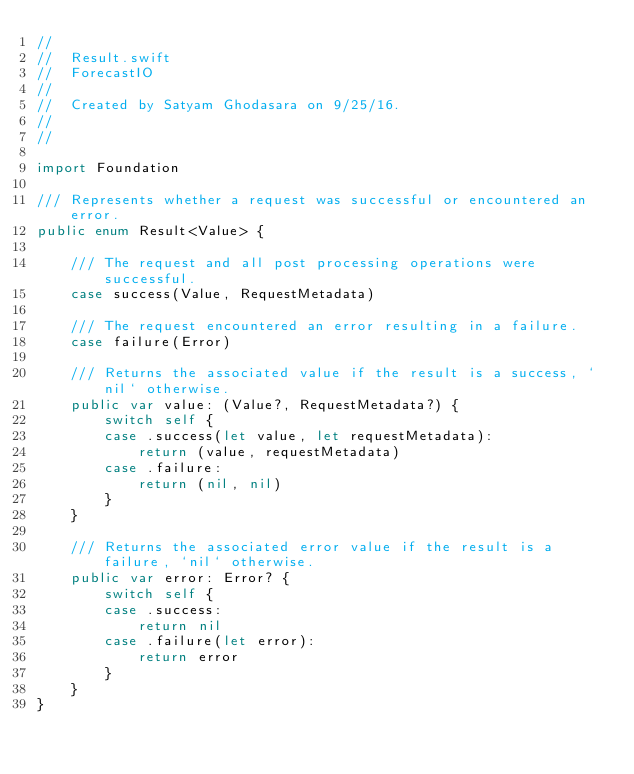Convert code to text. <code><loc_0><loc_0><loc_500><loc_500><_Swift_>//
//  Result.swift
//  ForecastIO
//
//  Created by Satyam Ghodasara on 9/25/16.
//
//

import Foundation

/// Represents whether a request was successful or encountered an error.
public enum Result<Value> {
    
    /// The request and all post processing operations were successful.
    case success(Value, RequestMetadata)
    
    /// The request encountered an error resulting in a failure.
    case failure(Error)
    
    /// Returns the associated value if the result is a success, `nil` otherwise.
    public var value: (Value?, RequestMetadata?) {
        switch self {
        case .success(let value, let requestMetadata):
            return (value, requestMetadata)
        case .failure:
            return (nil, nil)
        }
    }
    
    /// Returns the associated error value if the result is a failure, `nil` otherwise.
    public var error: Error? {
        switch self {
        case .success:
            return nil
        case .failure(let error):
            return error
        }
    }
}
</code> 